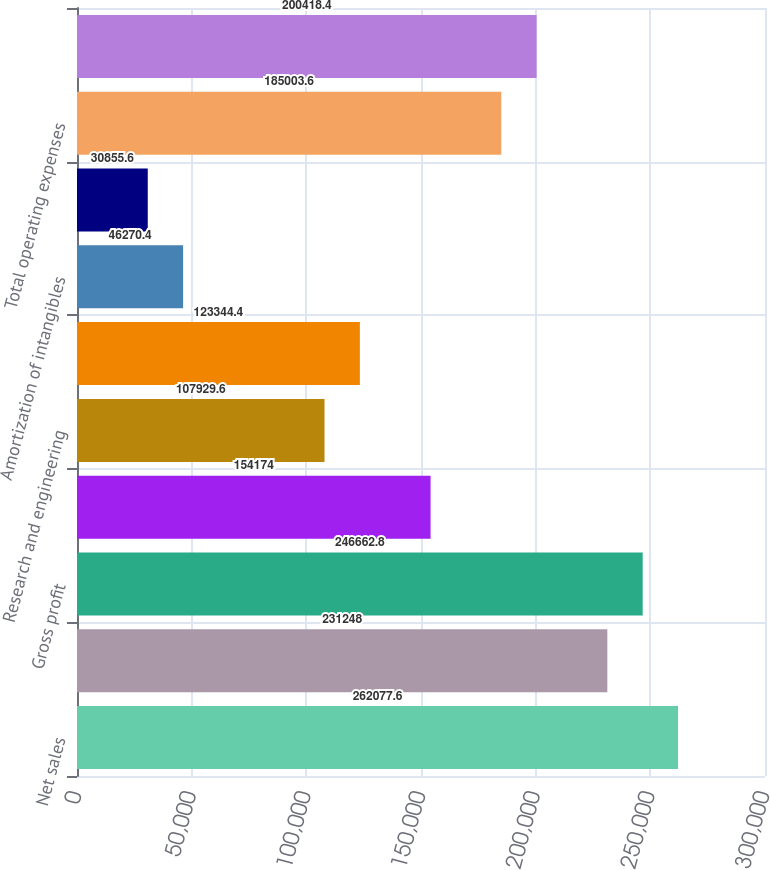<chart> <loc_0><loc_0><loc_500><loc_500><bar_chart><fcel>Net sales<fcel>Cost of sales<fcel>Gross profit<fcel>Selling and marketing<fcel>Research and engineering<fcel>General and administrative<fcel>Amortization of intangibles<fcel>Exit costs<fcel>Total operating expenses<fcel>Operating income<nl><fcel>262078<fcel>231248<fcel>246663<fcel>154174<fcel>107930<fcel>123344<fcel>46270.4<fcel>30855.6<fcel>185004<fcel>200418<nl></chart> 